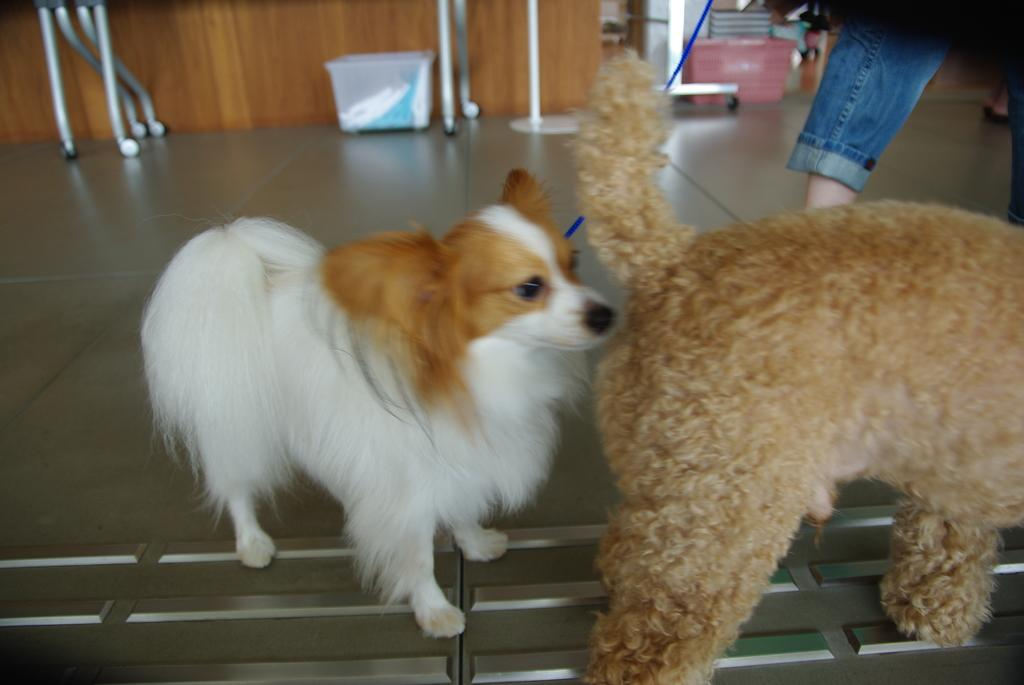What type of animals can be seen in the image? There are dogs in the image. Can you describe any part of a person in the image? The legs of a person are visible in the image. What is present on the floor in the background of the image? There are objects on the floor in the background of the image. What is located behind the dogs in the image? There is a wall in the background of the image. What type of lettuce is being used as a territory marker by the cattle in the image? There is no lettuce or cattle present in the image; it features dogs and a person's legs. 